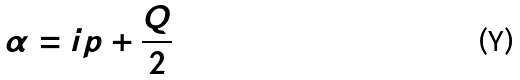<formula> <loc_0><loc_0><loc_500><loc_500>\alpha = i p + \frac { Q } { 2 }</formula> 